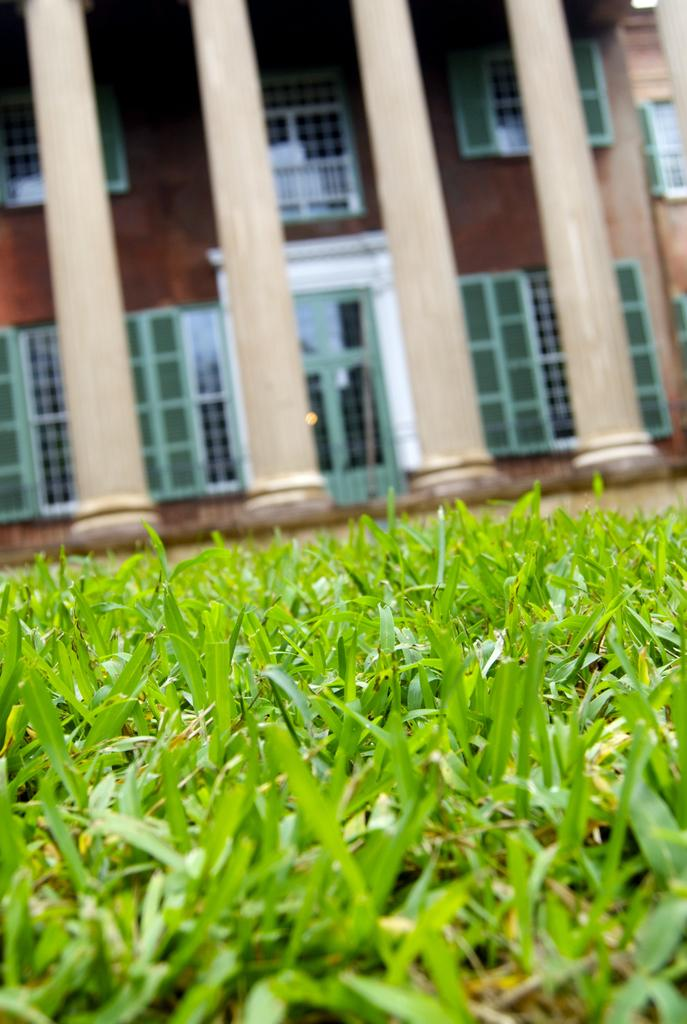What type of vegetation is present on the ground in the image? There is grass on the ground in the image. How many pillars can be seen in the image? There are four pillars in the image. What is the color of the pillars? The pillars are in cream color. What is the color of the building behind the pillars? There is a brown color building behind the pillars. What type of plate is being used to start the race in the image? There is no race or plate present in the image. What type of gate can be seen in the image? There is no gate present in the image. 